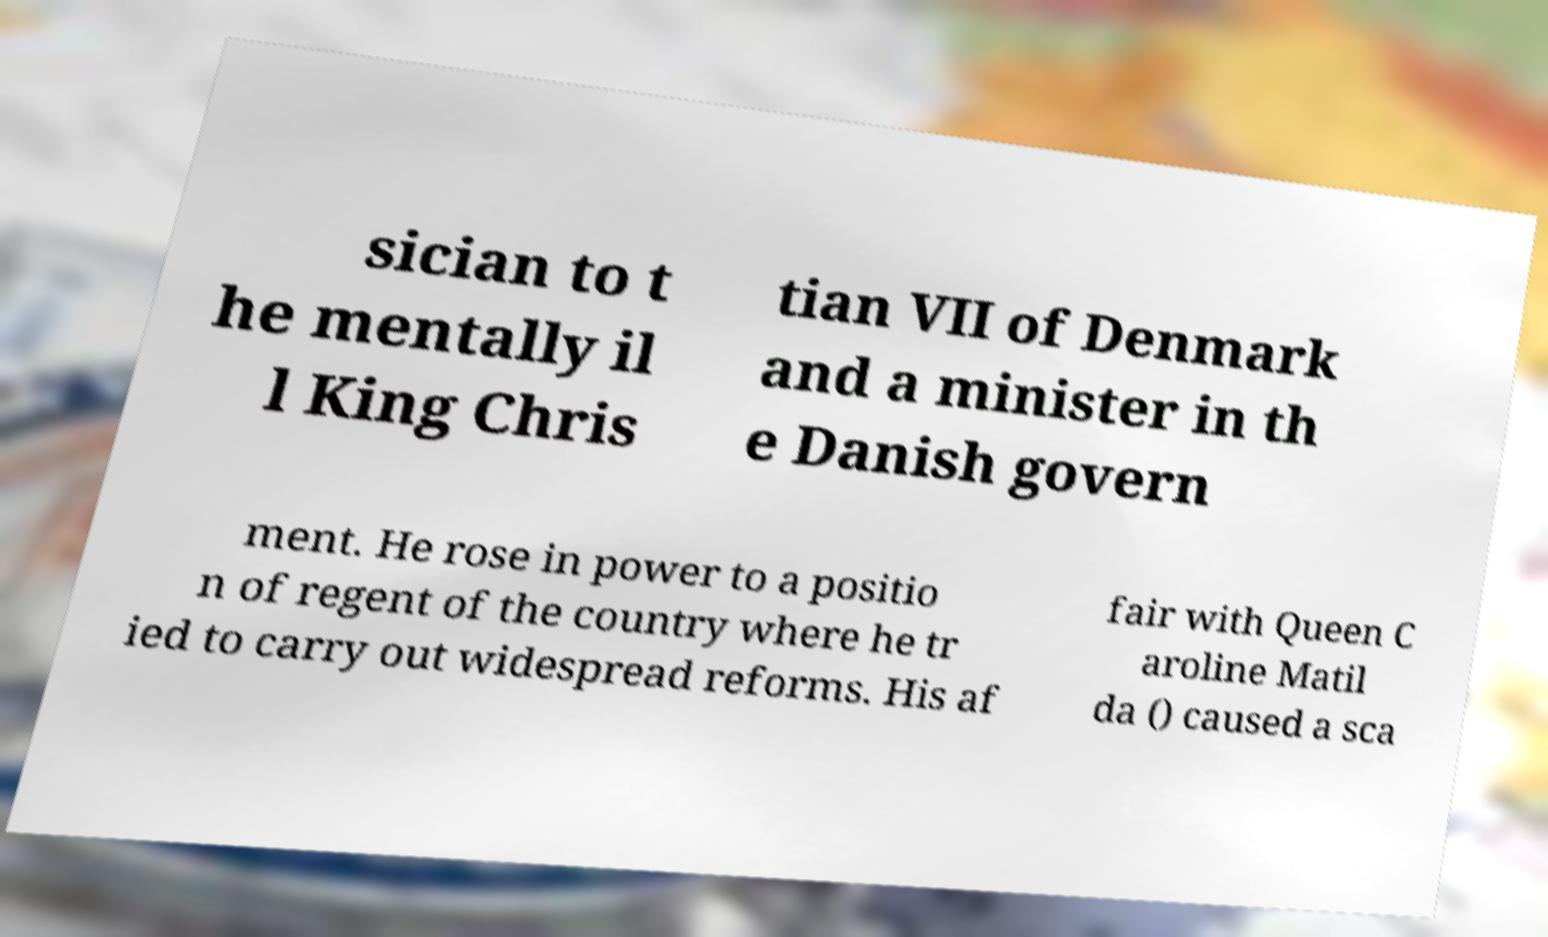Could you extract and type out the text from this image? sician to t he mentally il l King Chris tian VII of Denmark and a minister in th e Danish govern ment. He rose in power to a positio n of regent of the country where he tr ied to carry out widespread reforms. His af fair with Queen C aroline Matil da () caused a sca 